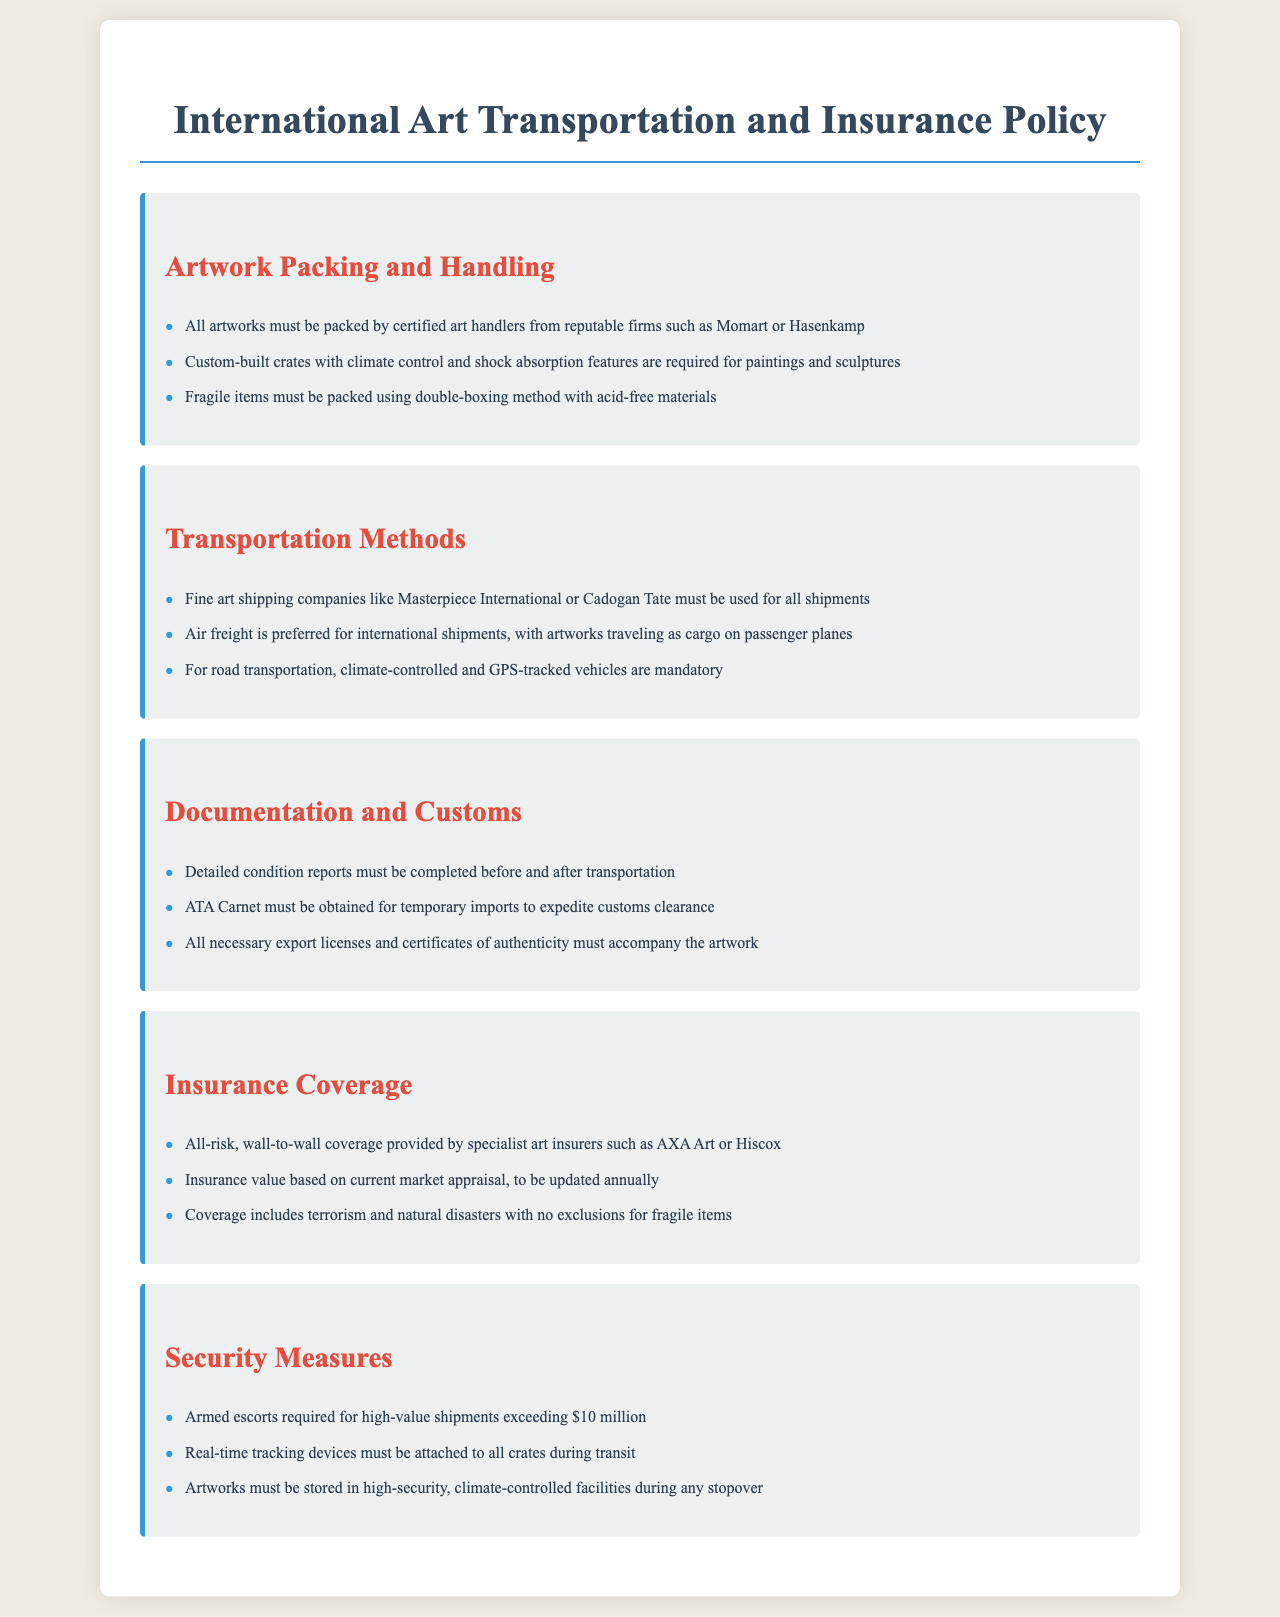What are the names of two certified art handlers? The document lists "Momart" and "Hasenkamp" as examples of certified art handlers for packing artworks.
Answer: Momart, Hasenkamp What type of insurance coverage is required? The document specifies that “all-risk, wall-to-wall coverage” is provided by specialist art insurers as a requirement.
Answer: All-risk, wall-to-wall coverage What is the required document for temporary imports? The document states that an "ATA Carnet" must be obtained for expediting customs clearance for temporary imports.
Answer: ATA Carnet What shipment value requires armed escorts? The policy indicates that "high-value shipments exceeding $10 million" require armed escorts for transportation.
Answer: $10 million Which transportation method is preferred for international shipments? The policy states that "air freight" is the preferred method for transporting artworks internationally.
Answer: Air freight What must accompany artworks for customs? It is required that "all necessary export licenses and certificates of authenticity" accompany the artwork during transportation for customs purposes.
Answer: Export licenses and certificates of authenticity What feature must custom-built crates have? According to the policy, custom-built crates must have "climate control and shock absorption features" for packing artworks.
Answer: Climate control and shock absorption features What type of vehicles is mandatory for road transportation? The document stipulates that "climate-controlled and GPS-tracked vehicles" are mandatory for road transportation of artworks.
Answer: Climate-controlled and GPS-tracked vehicles Which companies are named for fine art shipping? The policy lists "Masterpiece International" and "Cadogan Tate" as examples of fine art shipping companies that must be used.
Answer: Masterpiece International, Cadogan Tate 